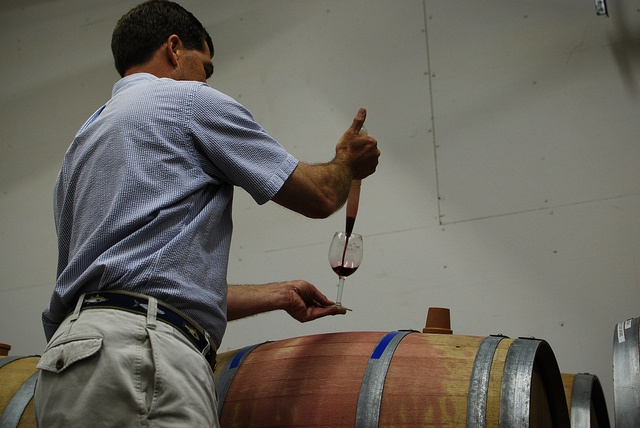Describe the objects in this image and their specific colors. I can see people in black, gray, and darkgray tones and wine glass in black and gray tones in this image. 